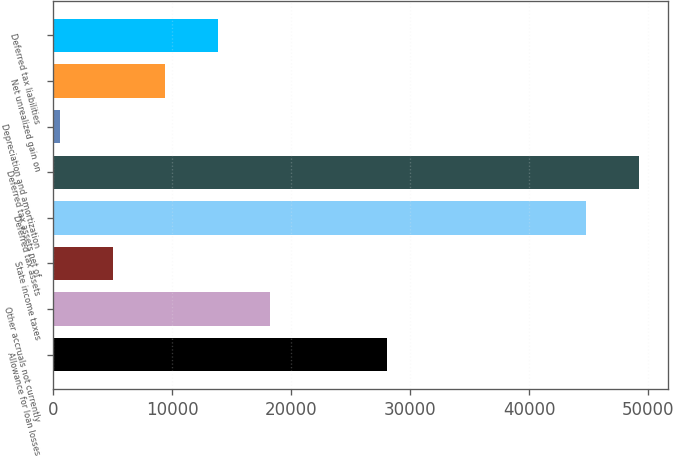Convert chart. <chart><loc_0><loc_0><loc_500><loc_500><bar_chart><fcel>Allowance for loan losses<fcel>Other accruals not currently<fcel>State income taxes<fcel>Deferred tax assets<fcel>Deferred tax assets net of<fcel>Depreciation and amortization<fcel>Net unrealized gain on<fcel>Deferred tax liabilities<nl><fcel>28023<fcel>18269.6<fcel>5017.4<fcel>44774<fcel>49191.4<fcel>600<fcel>9434.8<fcel>13852.2<nl></chart> 